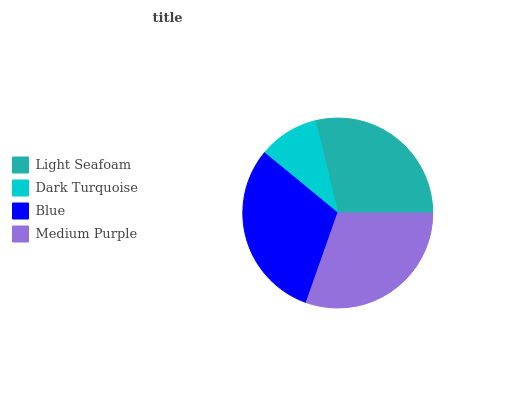Is Dark Turquoise the minimum?
Answer yes or no. Yes. Is Blue the maximum?
Answer yes or no. Yes. Is Blue the minimum?
Answer yes or no. No. Is Dark Turquoise the maximum?
Answer yes or no. No. Is Blue greater than Dark Turquoise?
Answer yes or no. Yes. Is Dark Turquoise less than Blue?
Answer yes or no. Yes. Is Dark Turquoise greater than Blue?
Answer yes or no. No. Is Blue less than Dark Turquoise?
Answer yes or no. No. Is Medium Purple the high median?
Answer yes or no. Yes. Is Light Seafoam the low median?
Answer yes or no. Yes. Is Dark Turquoise the high median?
Answer yes or no. No. Is Medium Purple the low median?
Answer yes or no. No. 